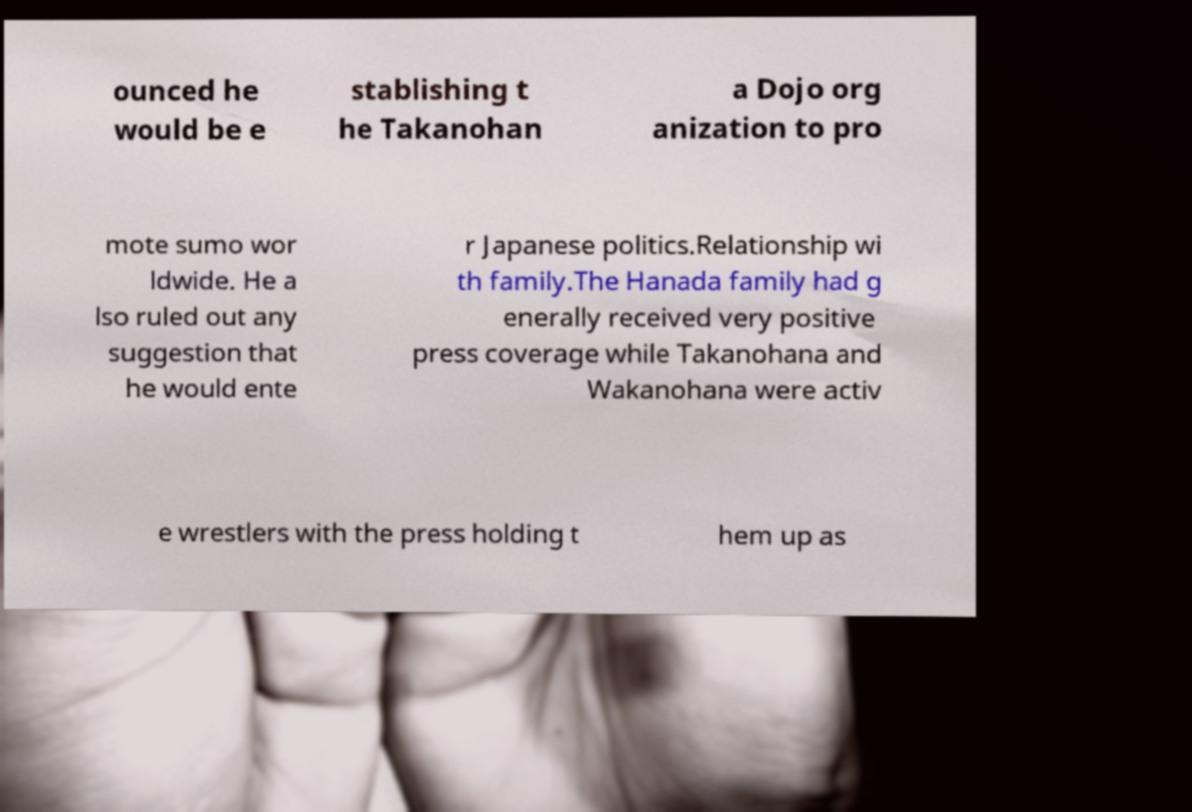For documentation purposes, I need the text within this image transcribed. Could you provide that? ounced he would be e stablishing t he Takanohan a Dojo org anization to pro mote sumo wor ldwide. He a lso ruled out any suggestion that he would ente r Japanese politics.Relationship wi th family.The Hanada family had g enerally received very positive press coverage while Takanohana and Wakanohana were activ e wrestlers with the press holding t hem up as 